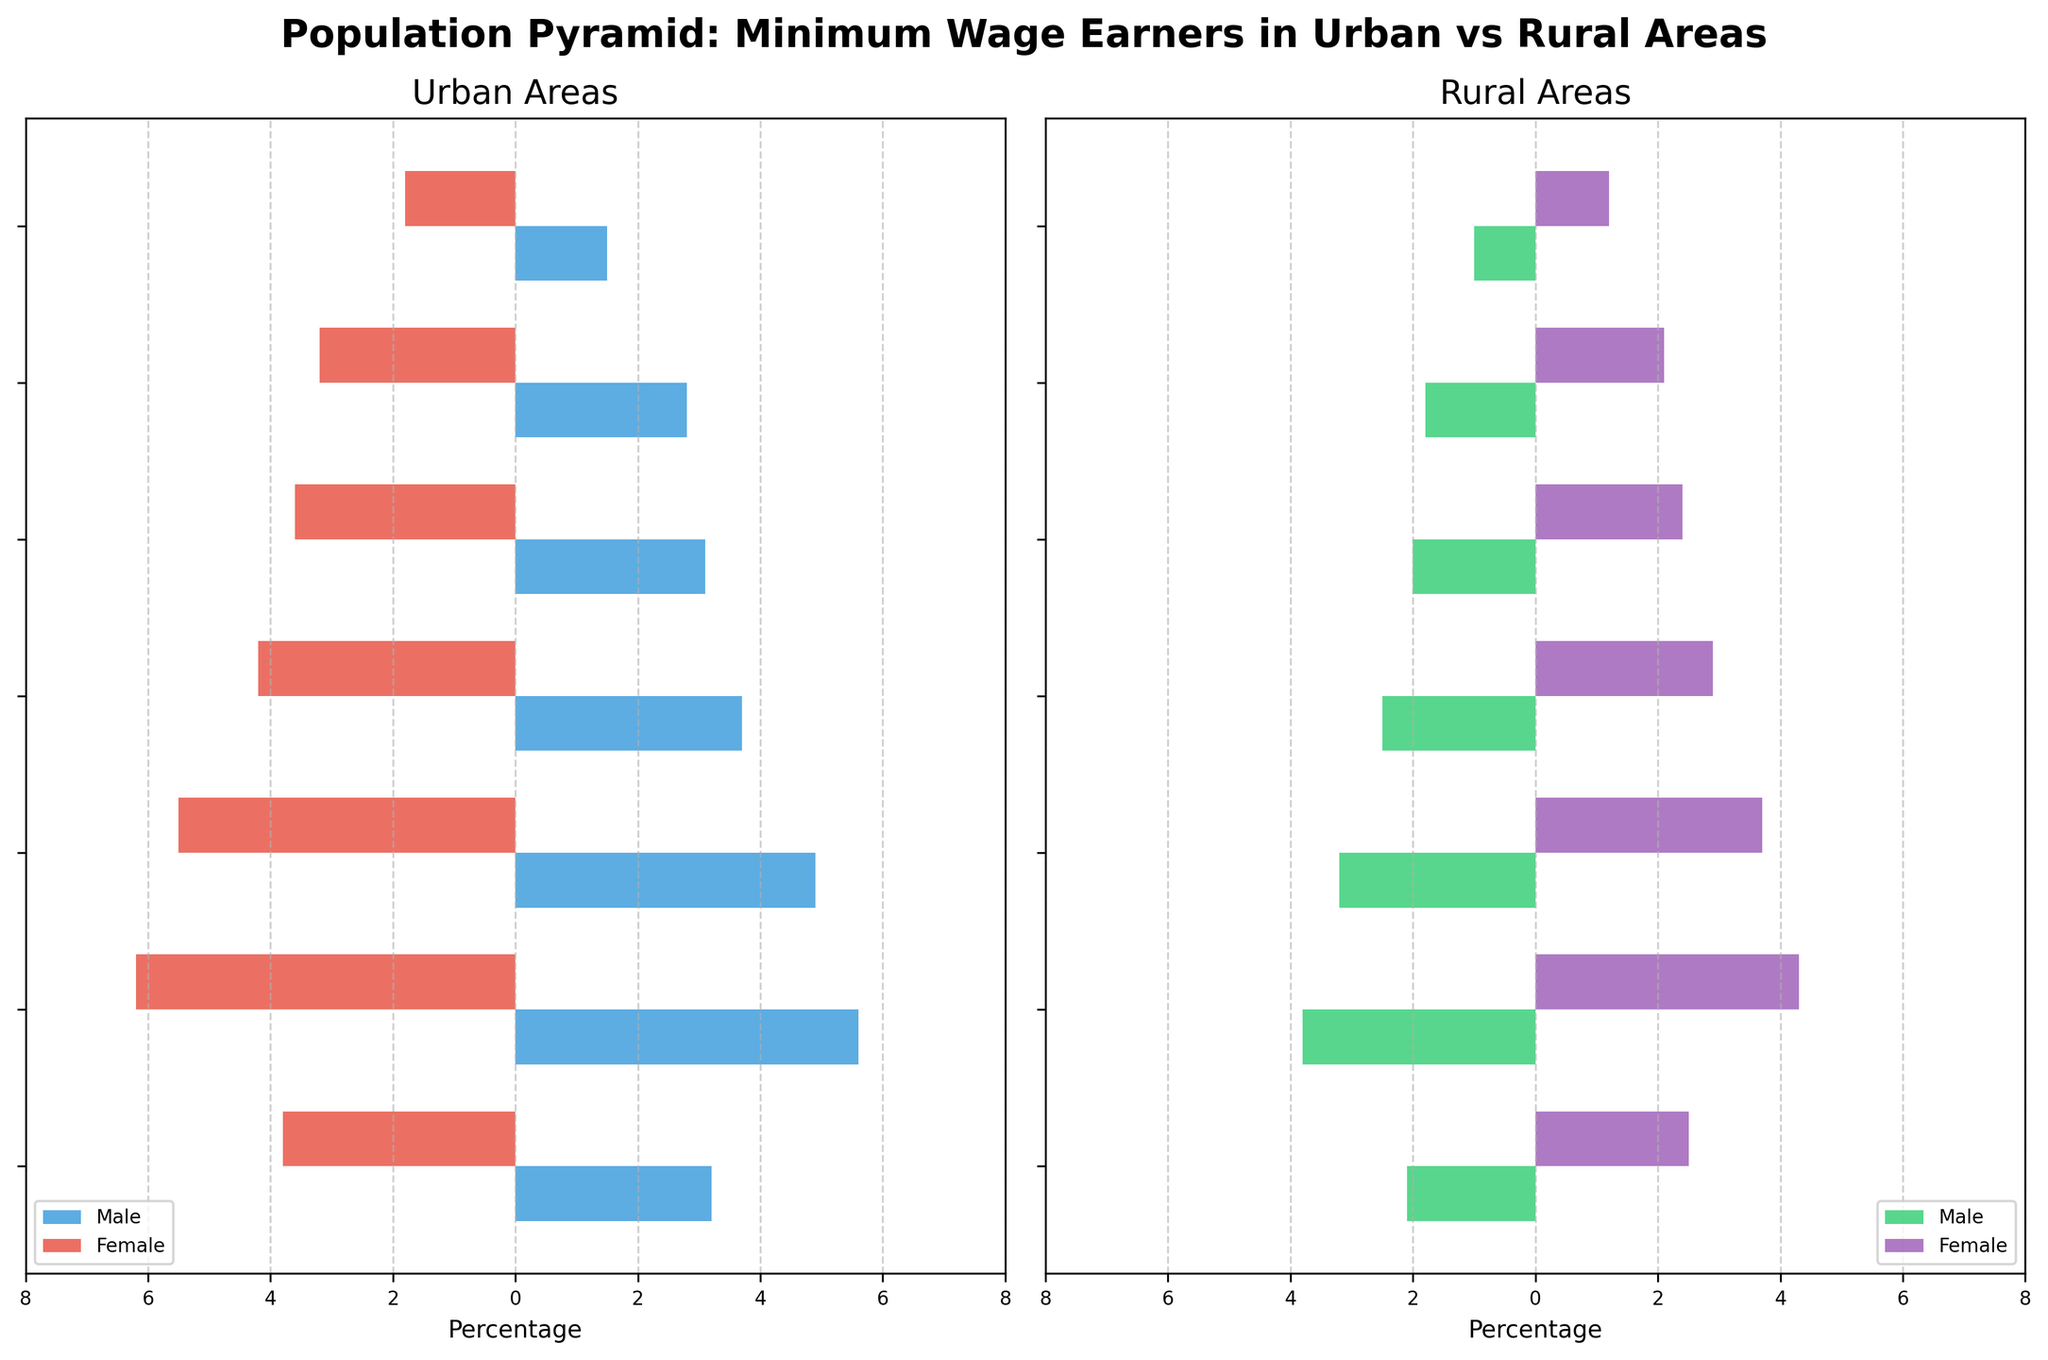What is the title of the figure? The title of the figure is located at the top and gives a summary of what the figure is about.
Answer: Population Pyramid: Minimum Wage Earners in Urban vs Rural Areas What age group has the highest percentage of minimum wage earners in urban areas? Look for the age group bar in the urban areas plot with the longest length on both sides. In both the male and female categories, the age group 20-24 has the highest percentages.
Answer: 20-24 How does the percentage of urban males in the 45-54 age group compare to rural males in the same age group? Compare the lengths of the bars for males in the 45-54 age group for both urban and rural areas. The urban bar is longer than the rural one. Urban males around 3.1% while rural males around 2.0%.
Answer: Urban males are higher What is the gender difference in the rural 25-34 age group? In the rural plot, find the 25-34 age group and compare the lengths of the male and female bars. Rural males are at 3.2% and rural females are at 3.7%.
Answer: Females are 0.5% higher Which gender has a higher percentage of minimum wage earners in the 55-64 age group in urban areas? In the urban areas plot, compare the lengths of the bars for males and females in the 55-64 age group. The female bar is longer.
Answer: Females What is the average percentage of minimum wage earners in the 16-19 age group for both rural males and females? Add the percentages of rural males and females in the 16-19 age group and divide by 2. (2.1% + 2.5%) / 2 = 2.3%.
Answer: 2.3% Which area (Urban or Rural) has a higher percentage for the age group 65+ in both genders combined? Sum the percentages for both genders in the 65+ age group for both urban and rural areas. Urban: 1.5% (male) + 1.8% (female) = 3.3%, Rural: 1.0% (male) + 1.2% (female) = 2.2%. Urban has a higher value.
Answer: Urban What is the total difference in percentage between urban and rural females in the 20-24 age group? Subtract the rural female percentage from the urban female percentage in the 20-24 age group. 6.2% (Urban) - 4.3% (Rural) = 1.9%.
Answer: 1.9% What are the maximum percentages for urban and rural males in any age group and which age group do they belong to? Identify the longest bar for males in both urban and rural plots and note the corresponding age group. Urban males have a maximum of 5.6% in 20-24 age, while rural males have a maximum of 3.8% in 20-24 age.
Answer: Urban: 5.6% (20-24), Rural: 3.8% (20-24) 